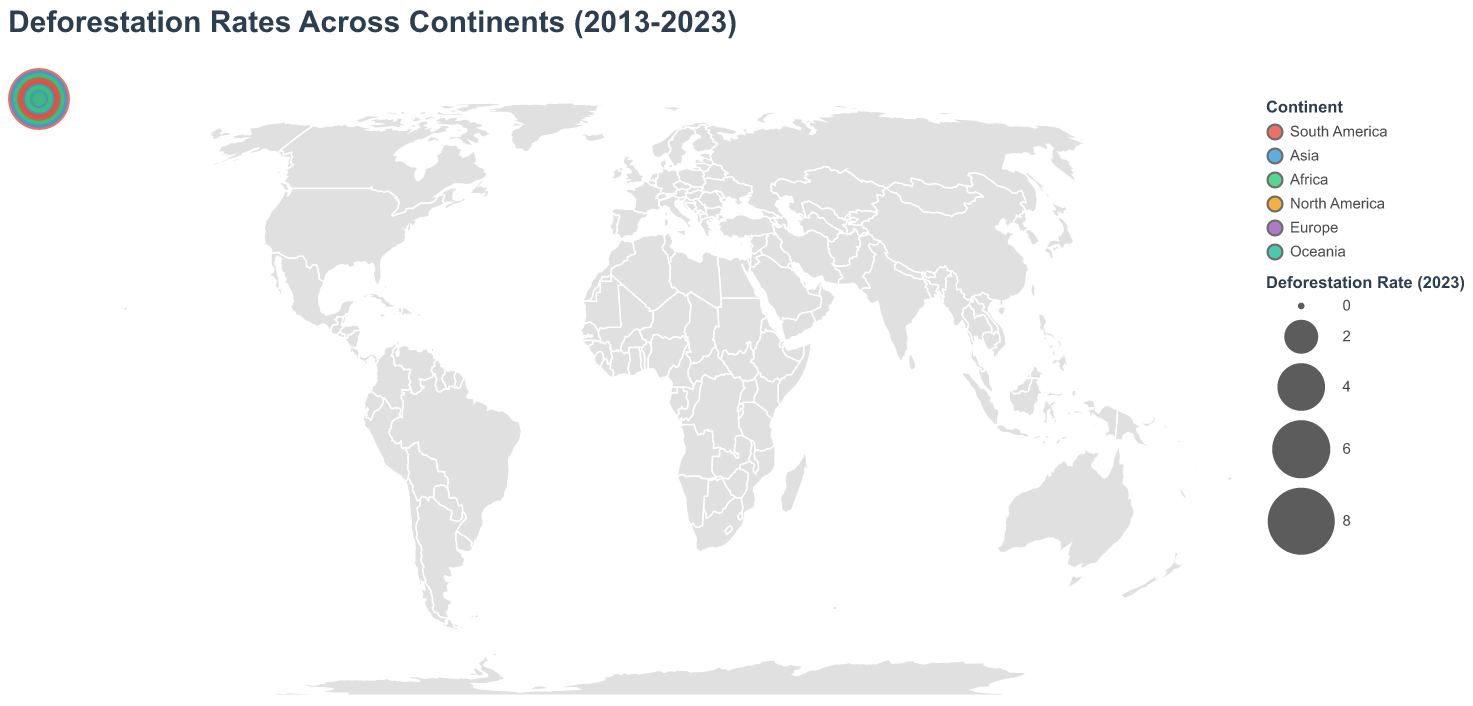What is the title of the figure? The title is usually located at the top of the figure. In this case, it is stated clearly.
Answer: Deforestation Rates Across Continents (2013-2023) Which continent had the highest deforestation rate in 2023? We need to look at the color legend and find the largest circle in 2023. The corresponding color to the largest circle represents the continent.
Answer: South America How did Brazil's deforestation rate change from 2013 to 2023? By checking the data on Brazil for the years 2013 and 2023, we observe the rate increased from 5.9 in 2013 to 6.8 in 2023.
Answer: Increased Compare the deforestation rates of Indonesia and Brazil in 2023. Which one is higher? By referring to the tooltip for both countries, we see Indonesia’s rate is 5.9 and Brazil’s rate is 6.8 in 2023.
Answer: Brazil What is the deforestation rate for the Democratic Republic of Congo in 2018? The tooltip shows the rate for every year; for the Democratic Republic of Congo in 2018, it is 4.2.
Answer: 4.2 Which country in North America had a consistent increase in deforestation rates over the decade? Checking the North America countries' tooltip, we observe rates for Canada and the United States. Only the United States shows a consistent increase from 2013 to 2023.
Answer: United States What is the average deforestation rate for South America in 2023? Calculate the average for Brazil, Bolivia, Colombia, Peru, and Paraguay using their 2023 values: (6.8 + 3.3 + 2.5 + 2.1 + 1.6) / 5 = 16.3 / 5 = 3.26
Answer: 3.26 Which country had the largest decrease in deforestation rate from 2013 to 2023? By comparing the deforestation rates of each country for the years 2013 and 2023, we find Indonesia decreased from 7.3 to 5.9, which is the largest decrease of 1.4.
Answer: Indonesia How many continents are represented in the figure? The color legend shows distinct colors for each continent, and counting these colors gives six continents.
Answer: 6 Is there a country on the map where deforestation rates are below 1 in 2023? Which one(s)? Checking the tooltip for all countries in 2023, we observe only Canada has a rate below 1 in 2023 (0.2).
Answer: Canada 